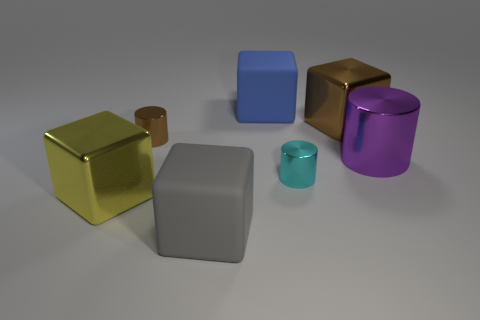Subtract all purple blocks. Subtract all yellow cylinders. How many blocks are left? 4 Add 2 metal objects. How many objects exist? 9 Subtract all cylinders. How many objects are left? 4 Add 1 small brown cylinders. How many small brown cylinders exist? 2 Subtract 0 blue cylinders. How many objects are left? 7 Subtract all brown spheres. Subtract all large gray things. How many objects are left? 6 Add 3 gray matte objects. How many gray matte objects are left? 4 